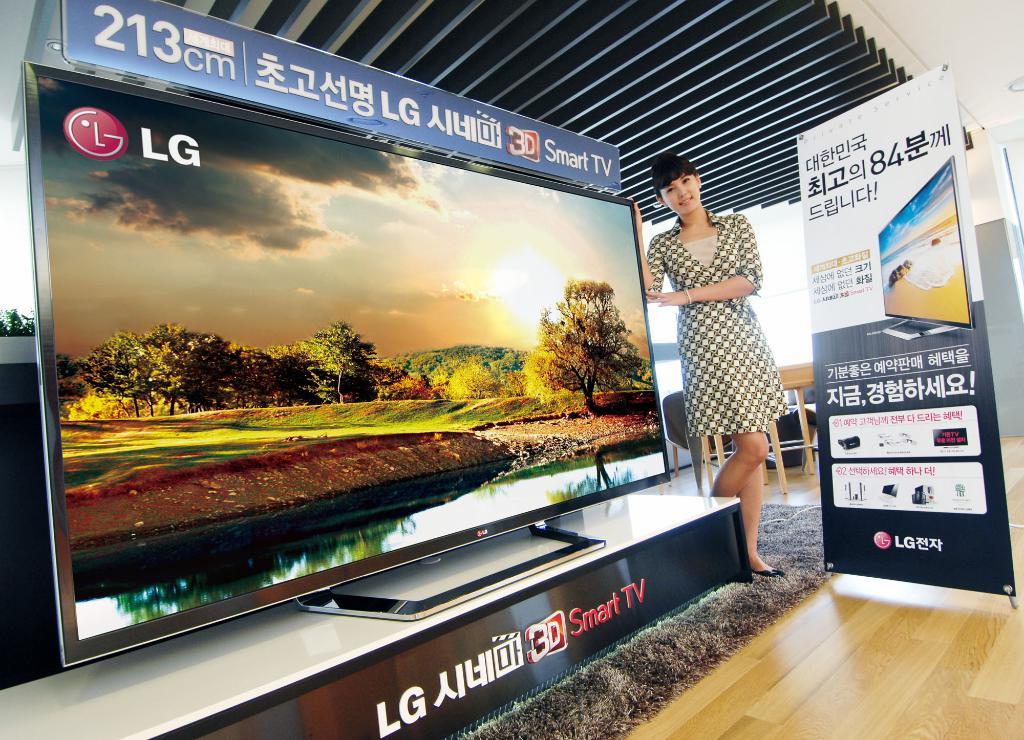What is the brand of the television?
Provide a short and direct response. Lg. According to the text on the bottom of the display, what is special about this tv?
Your answer should be very brief. Smart tv. 